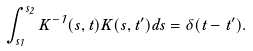Convert formula to latex. <formula><loc_0><loc_0><loc_500><loc_500>\int _ { s _ { 1 } } ^ { s _ { 2 } } K ^ { - 1 } ( s , t ) K ( s , t ^ { \prime } ) d s = \delta ( t - t ^ { \prime } ) .</formula> 